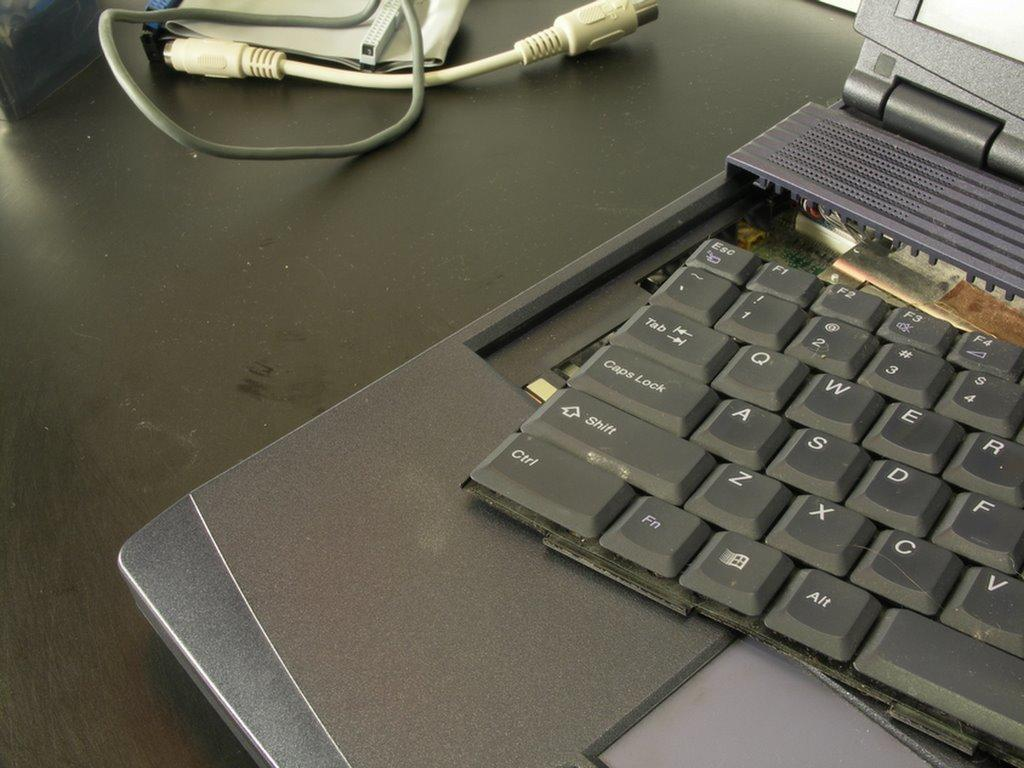<image>
Create a compact narrative representing the image presented. Corner of a broken laptop keyboard with Ctrl on the bottom left 